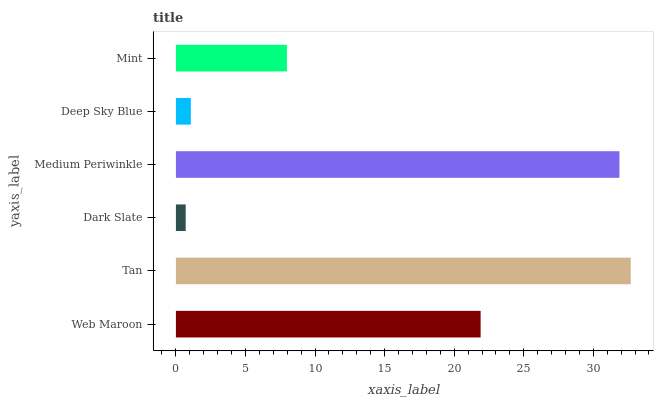Is Dark Slate the minimum?
Answer yes or no. Yes. Is Tan the maximum?
Answer yes or no. Yes. Is Tan the minimum?
Answer yes or no. No. Is Dark Slate the maximum?
Answer yes or no. No. Is Tan greater than Dark Slate?
Answer yes or no. Yes. Is Dark Slate less than Tan?
Answer yes or no. Yes. Is Dark Slate greater than Tan?
Answer yes or no. No. Is Tan less than Dark Slate?
Answer yes or no. No. Is Web Maroon the high median?
Answer yes or no. Yes. Is Mint the low median?
Answer yes or no. Yes. Is Dark Slate the high median?
Answer yes or no. No. Is Web Maroon the low median?
Answer yes or no. No. 